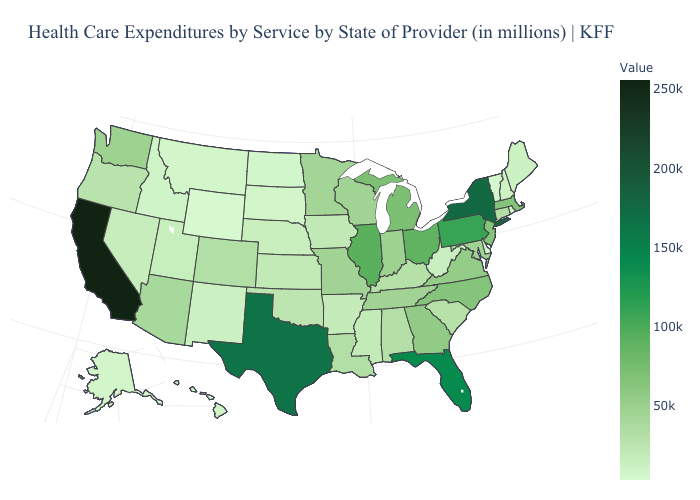Among the states that border Delaware , does Pennsylvania have the highest value?
Keep it brief. Yes. Does Ohio have the lowest value in the MidWest?
Write a very short answer. No. Does Delaware have the lowest value in the USA?
Be succinct. No. Which states hav the highest value in the South?
Quick response, please. Texas. Does California have the highest value in the West?
Concise answer only. Yes. 